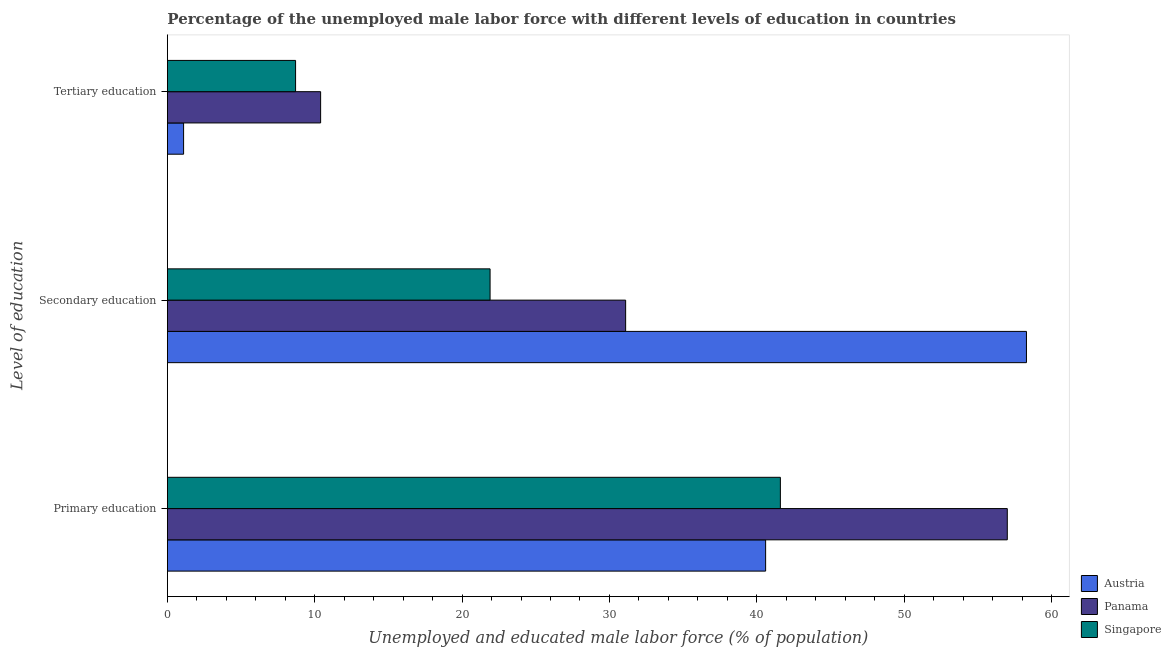How many different coloured bars are there?
Give a very brief answer. 3. What is the label of the 3rd group of bars from the top?
Give a very brief answer. Primary education. What is the percentage of male labor force who received secondary education in Panama?
Your response must be concise. 31.1. Across all countries, what is the maximum percentage of male labor force who received secondary education?
Keep it short and to the point. 58.3. Across all countries, what is the minimum percentage of male labor force who received tertiary education?
Offer a terse response. 1.1. In which country was the percentage of male labor force who received tertiary education maximum?
Your answer should be compact. Panama. In which country was the percentage of male labor force who received secondary education minimum?
Your answer should be compact. Singapore. What is the total percentage of male labor force who received primary education in the graph?
Your answer should be compact. 139.2. What is the difference between the percentage of male labor force who received primary education in Singapore and that in Panama?
Ensure brevity in your answer.  -15.4. What is the difference between the percentage of male labor force who received primary education in Singapore and the percentage of male labor force who received tertiary education in Austria?
Provide a short and direct response. 40.5. What is the average percentage of male labor force who received primary education per country?
Provide a succinct answer. 46.4. What is the difference between the percentage of male labor force who received secondary education and percentage of male labor force who received primary education in Panama?
Keep it short and to the point. -25.9. In how many countries, is the percentage of male labor force who received primary education greater than 20 %?
Provide a short and direct response. 3. What is the ratio of the percentage of male labor force who received secondary education in Panama to that in Singapore?
Offer a very short reply. 1.42. Is the difference between the percentage of male labor force who received secondary education in Singapore and Austria greater than the difference between the percentage of male labor force who received primary education in Singapore and Austria?
Your answer should be very brief. No. What is the difference between the highest and the second highest percentage of male labor force who received primary education?
Provide a short and direct response. 15.4. What is the difference between the highest and the lowest percentage of male labor force who received tertiary education?
Make the answer very short. 9.3. Is the sum of the percentage of male labor force who received tertiary education in Austria and Panama greater than the maximum percentage of male labor force who received secondary education across all countries?
Your answer should be compact. No. What does the 2nd bar from the top in Secondary education represents?
Offer a terse response. Panama. What does the 2nd bar from the bottom in Secondary education represents?
Provide a short and direct response. Panama. Is it the case that in every country, the sum of the percentage of male labor force who received primary education and percentage of male labor force who received secondary education is greater than the percentage of male labor force who received tertiary education?
Provide a succinct answer. Yes. Are all the bars in the graph horizontal?
Your answer should be very brief. Yes. How many countries are there in the graph?
Ensure brevity in your answer.  3. What is the difference between two consecutive major ticks on the X-axis?
Give a very brief answer. 10. Are the values on the major ticks of X-axis written in scientific E-notation?
Keep it short and to the point. No. Does the graph contain any zero values?
Provide a short and direct response. No. How many legend labels are there?
Your answer should be very brief. 3. What is the title of the graph?
Provide a succinct answer. Percentage of the unemployed male labor force with different levels of education in countries. Does "Northern Mariana Islands" appear as one of the legend labels in the graph?
Provide a short and direct response. No. What is the label or title of the X-axis?
Give a very brief answer. Unemployed and educated male labor force (% of population). What is the label or title of the Y-axis?
Ensure brevity in your answer.  Level of education. What is the Unemployed and educated male labor force (% of population) of Austria in Primary education?
Offer a terse response. 40.6. What is the Unemployed and educated male labor force (% of population) of Panama in Primary education?
Provide a succinct answer. 57. What is the Unemployed and educated male labor force (% of population) in Singapore in Primary education?
Your answer should be very brief. 41.6. What is the Unemployed and educated male labor force (% of population) of Austria in Secondary education?
Your answer should be very brief. 58.3. What is the Unemployed and educated male labor force (% of population) of Panama in Secondary education?
Your answer should be very brief. 31.1. What is the Unemployed and educated male labor force (% of population) of Singapore in Secondary education?
Keep it short and to the point. 21.9. What is the Unemployed and educated male labor force (% of population) in Austria in Tertiary education?
Provide a succinct answer. 1.1. What is the Unemployed and educated male labor force (% of population) of Panama in Tertiary education?
Your answer should be compact. 10.4. What is the Unemployed and educated male labor force (% of population) of Singapore in Tertiary education?
Offer a terse response. 8.7. Across all Level of education, what is the maximum Unemployed and educated male labor force (% of population) in Austria?
Make the answer very short. 58.3. Across all Level of education, what is the maximum Unemployed and educated male labor force (% of population) in Singapore?
Give a very brief answer. 41.6. Across all Level of education, what is the minimum Unemployed and educated male labor force (% of population) in Austria?
Your response must be concise. 1.1. Across all Level of education, what is the minimum Unemployed and educated male labor force (% of population) of Panama?
Your response must be concise. 10.4. Across all Level of education, what is the minimum Unemployed and educated male labor force (% of population) in Singapore?
Give a very brief answer. 8.7. What is the total Unemployed and educated male labor force (% of population) in Austria in the graph?
Provide a succinct answer. 100. What is the total Unemployed and educated male labor force (% of population) in Panama in the graph?
Your answer should be compact. 98.5. What is the total Unemployed and educated male labor force (% of population) in Singapore in the graph?
Your answer should be compact. 72.2. What is the difference between the Unemployed and educated male labor force (% of population) of Austria in Primary education and that in Secondary education?
Make the answer very short. -17.7. What is the difference between the Unemployed and educated male labor force (% of population) of Panama in Primary education and that in Secondary education?
Keep it short and to the point. 25.9. What is the difference between the Unemployed and educated male labor force (% of population) of Singapore in Primary education and that in Secondary education?
Keep it short and to the point. 19.7. What is the difference between the Unemployed and educated male labor force (% of population) of Austria in Primary education and that in Tertiary education?
Keep it short and to the point. 39.5. What is the difference between the Unemployed and educated male labor force (% of population) in Panama in Primary education and that in Tertiary education?
Your answer should be very brief. 46.6. What is the difference between the Unemployed and educated male labor force (% of population) in Singapore in Primary education and that in Tertiary education?
Your answer should be compact. 32.9. What is the difference between the Unemployed and educated male labor force (% of population) of Austria in Secondary education and that in Tertiary education?
Your answer should be compact. 57.2. What is the difference between the Unemployed and educated male labor force (% of population) of Panama in Secondary education and that in Tertiary education?
Provide a succinct answer. 20.7. What is the difference between the Unemployed and educated male labor force (% of population) in Singapore in Secondary education and that in Tertiary education?
Your answer should be very brief. 13.2. What is the difference between the Unemployed and educated male labor force (% of population) of Austria in Primary education and the Unemployed and educated male labor force (% of population) of Panama in Secondary education?
Keep it short and to the point. 9.5. What is the difference between the Unemployed and educated male labor force (% of population) in Austria in Primary education and the Unemployed and educated male labor force (% of population) in Singapore in Secondary education?
Your response must be concise. 18.7. What is the difference between the Unemployed and educated male labor force (% of population) in Panama in Primary education and the Unemployed and educated male labor force (% of population) in Singapore in Secondary education?
Your response must be concise. 35.1. What is the difference between the Unemployed and educated male labor force (% of population) of Austria in Primary education and the Unemployed and educated male labor force (% of population) of Panama in Tertiary education?
Your answer should be very brief. 30.2. What is the difference between the Unemployed and educated male labor force (% of population) of Austria in Primary education and the Unemployed and educated male labor force (% of population) of Singapore in Tertiary education?
Your answer should be compact. 31.9. What is the difference between the Unemployed and educated male labor force (% of population) in Panama in Primary education and the Unemployed and educated male labor force (% of population) in Singapore in Tertiary education?
Offer a terse response. 48.3. What is the difference between the Unemployed and educated male labor force (% of population) in Austria in Secondary education and the Unemployed and educated male labor force (% of population) in Panama in Tertiary education?
Provide a short and direct response. 47.9. What is the difference between the Unemployed and educated male labor force (% of population) in Austria in Secondary education and the Unemployed and educated male labor force (% of population) in Singapore in Tertiary education?
Provide a succinct answer. 49.6. What is the difference between the Unemployed and educated male labor force (% of population) of Panama in Secondary education and the Unemployed and educated male labor force (% of population) of Singapore in Tertiary education?
Provide a short and direct response. 22.4. What is the average Unemployed and educated male labor force (% of population) of Austria per Level of education?
Ensure brevity in your answer.  33.33. What is the average Unemployed and educated male labor force (% of population) in Panama per Level of education?
Keep it short and to the point. 32.83. What is the average Unemployed and educated male labor force (% of population) in Singapore per Level of education?
Offer a terse response. 24.07. What is the difference between the Unemployed and educated male labor force (% of population) of Austria and Unemployed and educated male labor force (% of population) of Panama in Primary education?
Give a very brief answer. -16.4. What is the difference between the Unemployed and educated male labor force (% of population) of Austria and Unemployed and educated male labor force (% of population) of Panama in Secondary education?
Your answer should be compact. 27.2. What is the difference between the Unemployed and educated male labor force (% of population) of Austria and Unemployed and educated male labor force (% of population) of Singapore in Secondary education?
Your answer should be compact. 36.4. What is the difference between the Unemployed and educated male labor force (% of population) of Panama and Unemployed and educated male labor force (% of population) of Singapore in Tertiary education?
Offer a very short reply. 1.7. What is the ratio of the Unemployed and educated male labor force (% of population) in Austria in Primary education to that in Secondary education?
Keep it short and to the point. 0.7. What is the ratio of the Unemployed and educated male labor force (% of population) in Panama in Primary education to that in Secondary education?
Provide a succinct answer. 1.83. What is the ratio of the Unemployed and educated male labor force (% of population) in Singapore in Primary education to that in Secondary education?
Your answer should be very brief. 1.9. What is the ratio of the Unemployed and educated male labor force (% of population) of Austria in Primary education to that in Tertiary education?
Give a very brief answer. 36.91. What is the ratio of the Unemployed and educated male labor force (% of population) of Panama in Primary education to that in Tertiary education?
Your response must be concise. 5.48. What is the ratio of the Unemployed and educated male labor force (% of population) of Singapore in Primary education to that in Tertiary education?
Give a very brief answer. 4.78. What is the ratio of the Unemployed and educated male labor force (% of population) in Austria in Secondary education to that in Tertiary education?
Give a very brief answer. 53. What is the ratio of the Unemployed and educated male labor force (% of population) of Panama in Secondary education to that in Tertiary education?
Your response must be concise. 2.99. What is the ratio of the Unemployed and educated male labor force (% of population) of Singapore in Secondary education to that in Tertiary education?
Ensure brevity in your answer.  2.52. What is the difference between the highest and the second highest Unemployed and educated male labor force (% of population) of Panama?
Provide a short and direct response. 25.9. What is the difference between the highest and the lowest Unemployed and educated male labor force (% of population) in Austria?
Ensure brevity in your answer.  57.2. What is the difference between the highest and the lowest Unemployed and educated male labor force (% of population) in Panama?
Offer a very short reply. 46.6. What is the difference between the highest and the lowest Unemployed and educated male labor force (% of population) of Singapore?
Your answer should be compact. 32.9. 